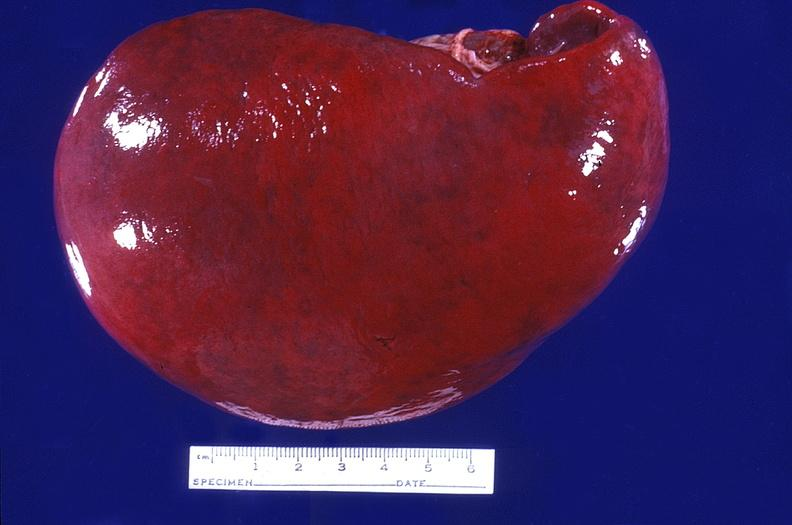does this image show spleen, normal?
Answer the question using a single word or phrase. Yes 